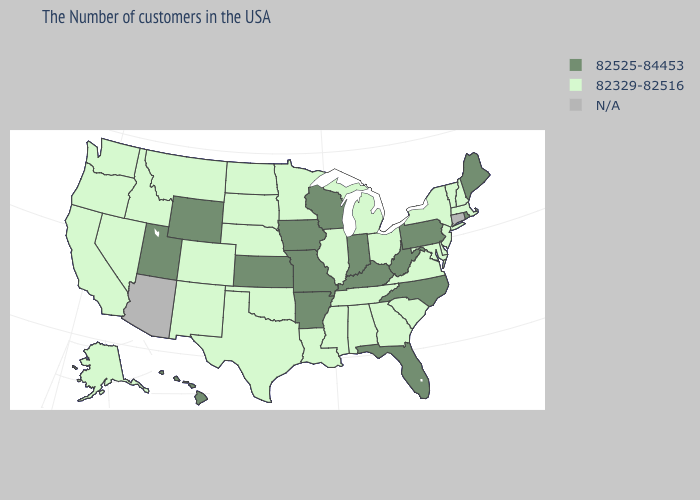What is the value of Oregon?
Give a very brief answer. 82329-82516. What is the value of Minnesota?
Give a very brief answer. 82329-82516. Among the states that border Utah , does Wyoming have the highest value?
Write a very short answer. Yes. Name the states that have a value in the range 82329-82516?
Concise answer only. Massachusetts, New Hampshire, Vermont, New York, New Jersey, Delaware, Maryland, Virginia, South Carolina, Ohio, Georgia, Michigan, Alabama, Tennessee, Illinois, Mississippi, Louisiana, Minnesota, Nebraska, Oklahoma, Texas, South Dakota, North Dakota, Colorado, New Mexico, Montana, Idaho, Nevada, California, Washington, Oregon, Alaska. Which states hav the highest value in the West?
Keep it brief. Wyoming, Utah, Hawaii. What is the highest value in the West ?
Quick response, please. 82525-84453. What is the highest value in the West ?
Quick response, please. 82525-84453. What is the value of New Hampshire?
Quick response, please. 82329-82516. What is the value of Oregon?
Keep it brief. 82329-82516. Which states have the highest value in the USA?
Give a very brief answer. Maine, Rhode Island, Pennsylvania, North Carolina, West Virginia, Florida, Kentucky, Indiana, Wisconsin, Missouri, Arkansas, Iowa, Kansas, Wyoming, Utah, Hawaii. What is the lowest value in states that border South Carolina?
Give a very brief answer. 82329-82516. Name the states that have a value in the range 82329-82516?
Concise answer only. Massachusetts, New Hampshire, Vermont, New York, New Jersey, Delaware, Maryland, Virginia, South Carolina, Ohio, Georgia, Michigan, Alabama, Tennessee, Illinois, Mississippi, Louisiana, Minnesota, Nebraska, Oklahoma, Texas, South Dakota, North Dakota, Colorado, New Mexico, Montana, Idaho, Nevada, California, Washington, Oregon, Alaska. What is the value of Virginia?
Write a very short answer. 82329-82516. What is the value of Florida?
Short answer required. 82525-84453. How many symbols are there in the legend?
Answer briefly. 3. 